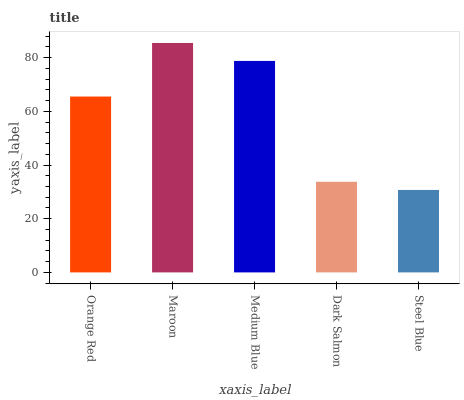Is Medium Blue the minimum?
Answer yes or no. No. Is Medium Blue the maximum?
Answer yes or no. No. Is Maroon greater than Medium Blue?
Answer yes or no. Yes. Is Medium Blue less than Maroon?
Answer yes or no. Yes. Is Medium Blue greater than Maroon?
Answer yes or no. No. Is Maroon less than Medium Blue?
Answer yes or no. No. Is Orange Red the high median?
Answer yes or no. Yes. Is Orange Red the low median?
Answer yes or no. Yes. Is Dark Salmon the high median?
Answer yes or no. No. Is Maroon the low median?
Answer yes or no. No. 